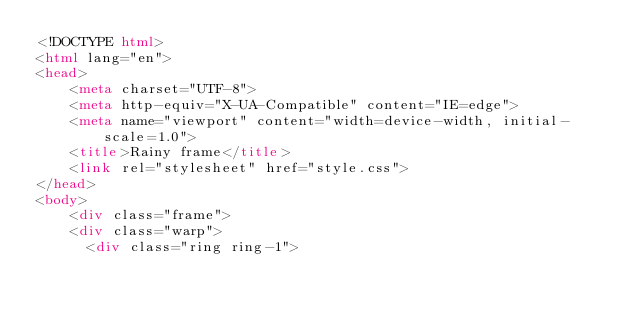<code> <loc_0><loc_0><loc_500><loc_500><_HTML_><!DOCTYPE html>
<html lang="en">
<head>
    <meta charset="UTF-8">
    <meta http-equiv="X-UA-Compatible" content="IE=edge">
    <meta name="viewport" content="width=device-width, initial-scale=1.0">
    <title>Rainy frame</title>
    <link rel="stylesheet" href="style.css">
</head>
<body>
    <div class="frame">
    <div class="warp">
      <div class="ring ring-1"></code> 